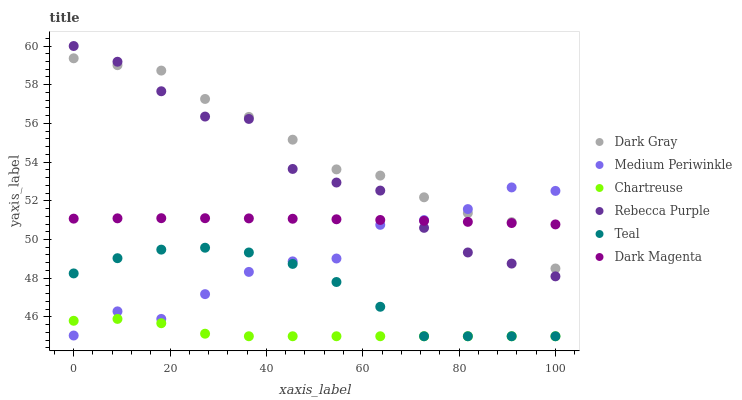Does Chartreuse have the minimum area under the curve?
Answer yes or no. Yes. Does Dark Gray have the maximum area under the curve?
Answer yes or no. Yes. Does Medium Periwinkle have the minimum area under the curve?
Answer yes or no. No. Does Medium Periwinkle have the maximum area under the curve?
Answer yes or no. No. Is Dark Magenta the smoothest?
Answer yes or no. Yes. Is Medium Periwinkle the roughest?
Answer yes or no. Yes. Is Dark Gray the smoothest?
Answer yes or no. No. Is Dark Gray the roughest?
Answer yes or no. No. Does Chartreuse have the lowest value?
Answer yes or no. Yes. Does Medium Periwinkle have the lowest value?
Answer yes or no. No. Does Rebecca Purple have the highest value?
Answer yes or no. Yes. Does Medium Periwinkle have the highest value?
Answer yes or no. No. Is Teal less than Dark Gray?
Answer yes or no. Yes. Is Dark Magenta greater than Teal?
Answer yes or no. Yes. Does Medium Periwinkle intersect Rebecca Purple?
Answer yes or no. Yes. Is Medium Periwinkle less than Rebecca Purple?
Answer yes or no. No. Is Medium Periwinkle greater than Rebecca Purple?
Answer yes or no. No. Does Teal intersect Dark Gray?
Answer yes or no. No. 